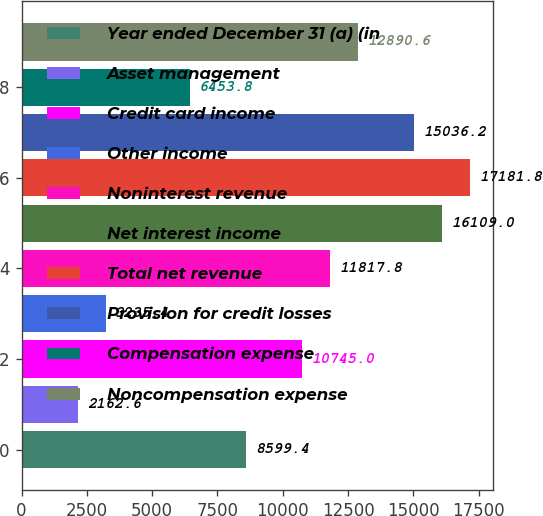Convert chart. <chart><loc_0><loc_0><loc_500><loc_500><bar_chart><fcel>Year ended December 31 (a) (in<fcel>Asset management<fcel>Credit card income<fcel>Other income<fcel>Noninterest revenue<fcel>Net interest income<fcel>Total net revenue<fcel>Provision for credit losses<fcel>Compensation expense<fcel>Noncompensation expense<nl><fcel>8599.4<fcel>2162.6<fcel>10745<fcel>3235.4<fcel>11817.8<fcel>16109<fcel>17181.8<fcel>15036.2<fcel>6453.8<fcel>12890.6<nl></chart> 